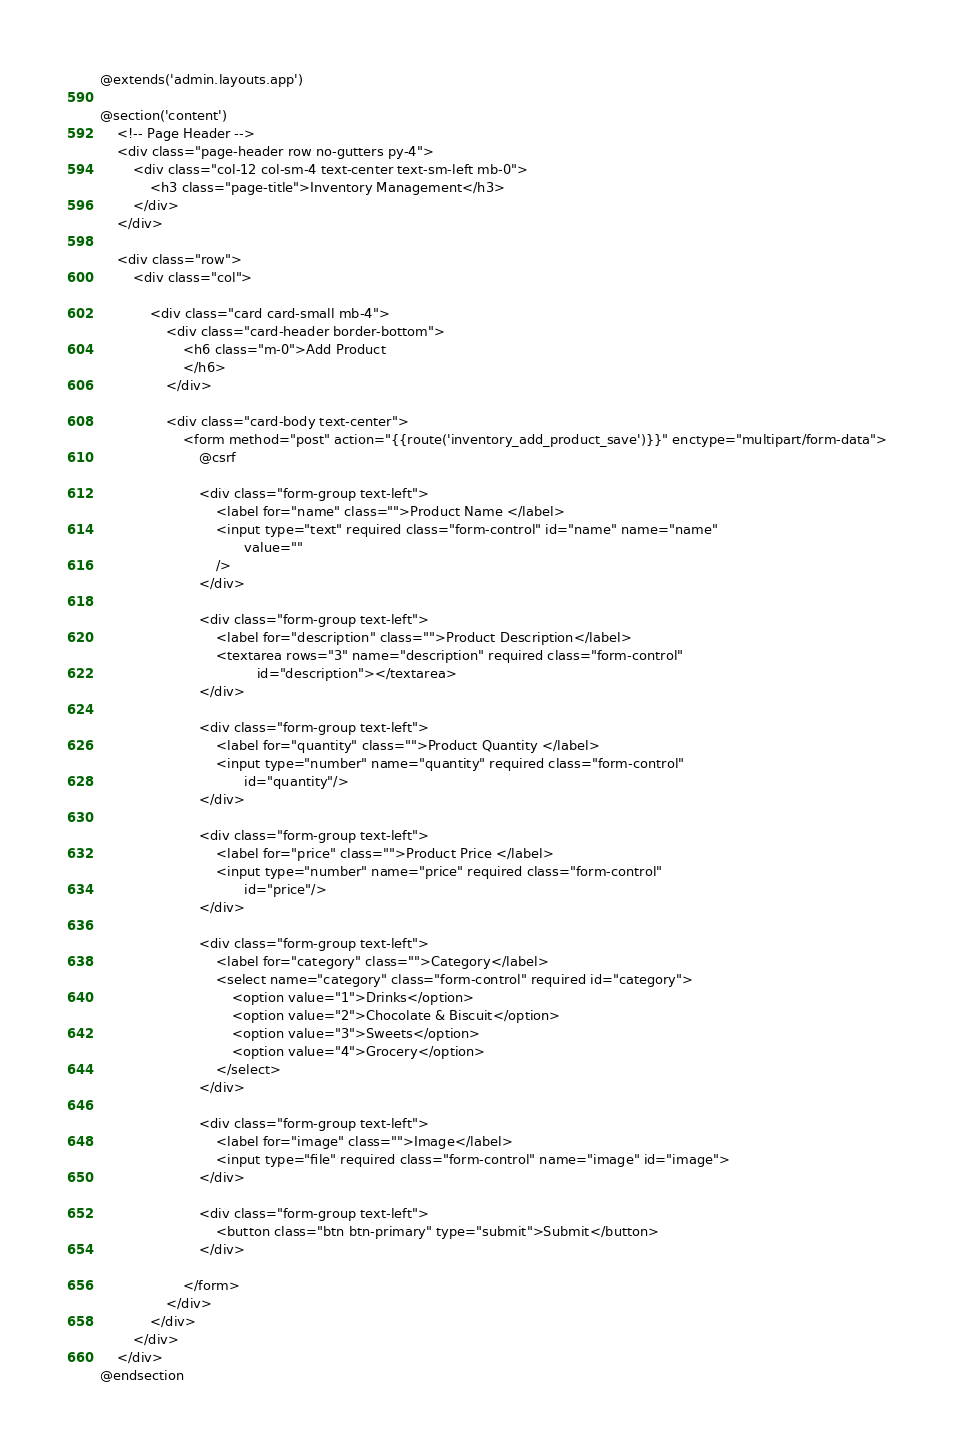<code> <loc_0><loc_0><loc_500><loc_500><_PHP_>@extends('admin.layouts.app')

@section('content')
    <!-- Page Header -->
    <div class="page-header row no-gutters py-4">
        <div class="col-12 col-sm-4 text-center text-sm-left mb-0">
            <h3 class="page-title">Inventory Management</h3>
        </div>
    </div>

    <div class="row">
        <div class="col">

            <div class="card card-small mb-4">
                <div class="card-header border-bottom">
                    <h6 class="m-0">Add Product
                    </h6>
                </div>

                <div class="card-body text-center">
                    <form method="post" action="{{route('inventory_add_product_save')}}" enctype="multipart/form-data">
                        @csrf

                        <div class="form-group text-left">
                            <label for="name" class="">Product Name </label>
                            <input type="text" required class="form-control" id="name" name="name"
                                   value=""
                            />
                        </div>

                        <div class="form-group text-left">
                            <label for="description" class="">Product Description</label>
                            <textarea rows="3" name="description" required class="form-control"
                                      id="description"></textarea>
                        </div>

                        <div class="form-group text-left">
                            <label for="quantity" class="">Product Quantity </label>
                            <input type="number" name="quantity" required class="form-control"
                                   id="quantity"/>
                        </div>

                        <div class="form-group text-left">
                            <label for="price" class="">Product Price </label>
                            <input type="number" name="price" required class="form-control"
                                   id="price"/>
                        </div>

                        <div class="form-group text-left">
                            <label for="category" class="">Category</label>
                            <select name="category" class="form-control" required id="category">
                                <option value="1">Drinks</option>
                                <option value="2">Chocolate & Biscuit</option>
                                <option value="3">Sweets</option>
                                <option value="4">Grocery</option>
                            </select>
                        </div>

                        <div class="form-group text-left">
                            <label for="image" class="">Image</label>
                            <input type="file" required class="form-control" name="image" id="image">
                        </div>

                        <div class="form-group text-left">
                            <button class="btn btn-primary" type="submit">Submit</button>
                        </div>

                    </form>
                </div>
            </div>
        </div>
    </div>
@endsection
</code> 